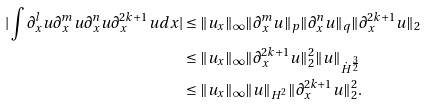Convert formula to latex. <formula><loc_0><loc_0><loc_500><loc_500>| \int \partial _ { x } ^ { l } u \partial _ { x } ^ { m } u \partial _ { x } ^ { n } u \partial _ { x } ^ { 2 k + 1 } u d x | & \leq \| u _ { x } \| _ { \infty } \| \partial _ { x } ^ { m } u \| _ { p } \| \partial _ { x } ^ { n } u \| _ { q } \| \partial _ { x } ^ { 2 k + 1 } u \| _ { 2 } \\ & \leq \| u _ { x } \| _ { \infty } \| \partial _ { x } ^ { 2 k + 1 } u \| _ { 2 } ^ { 2 } \| u \| _ { \dot { H } ^ { \frac { 3 } { 2 } } } \\ & \leq \| u _ { x } \| _ { \infty } \| u \| _ { H ^ { 2 } } \| \partial _ { x } ^ { 2 k + 1 } u \| _ { 2 } ^ { 2 } .</formula> 